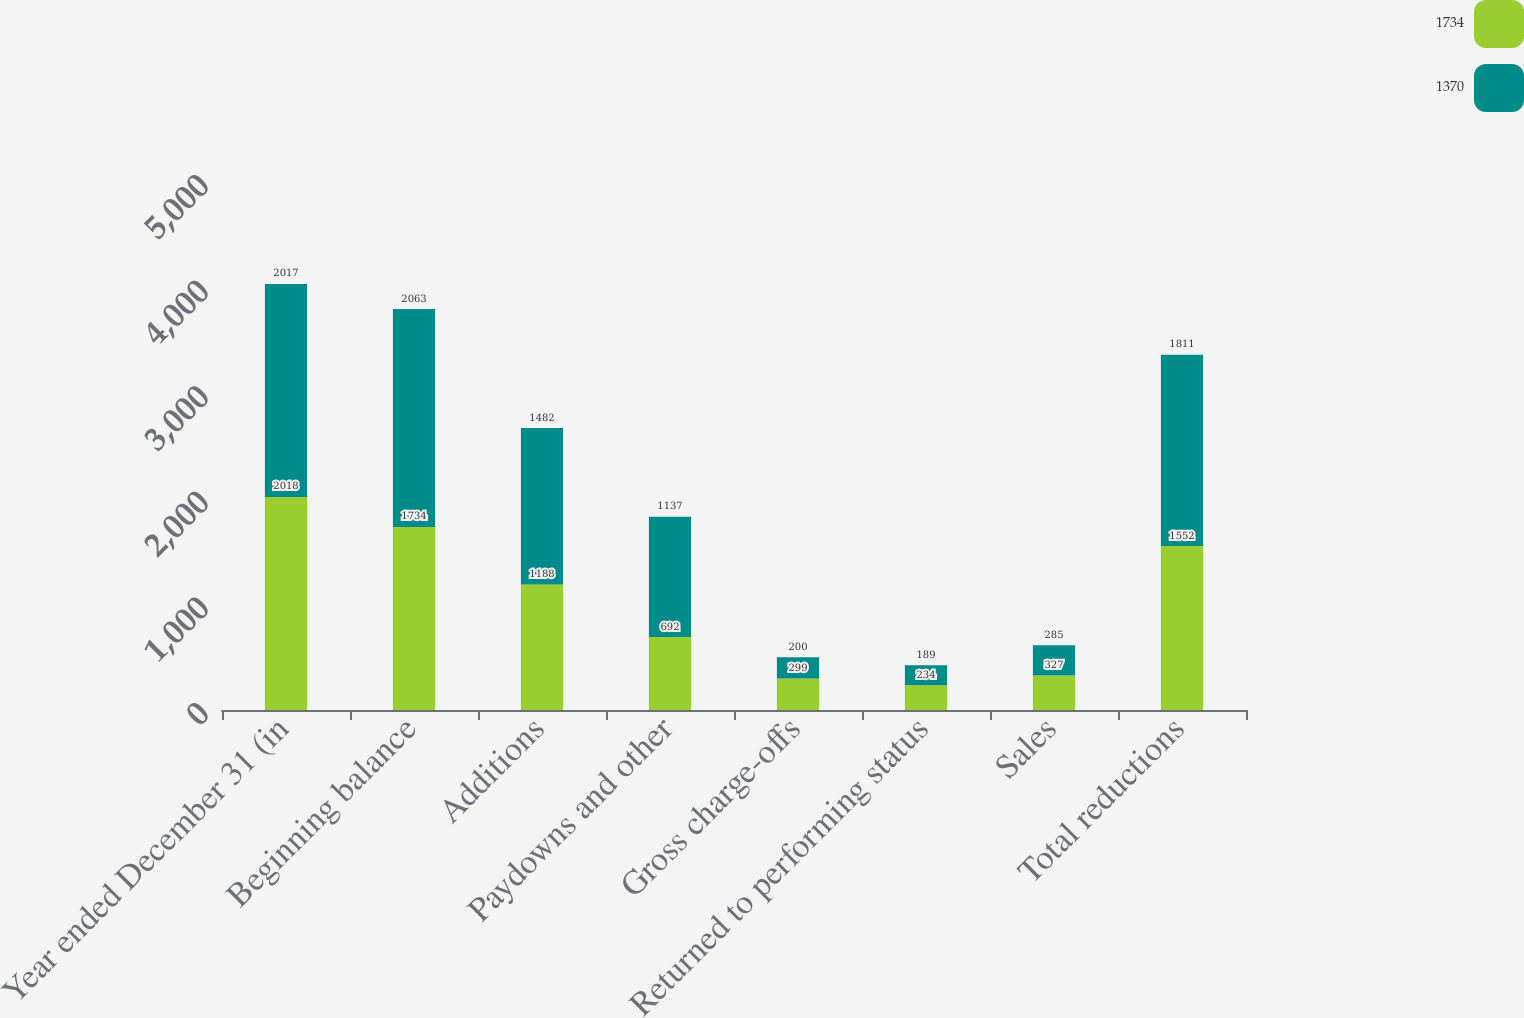Convert chart to OTSL. <chart><loc_0><loc_0><loc_500><loc_500><stacked_bar_chart><ecel><fcel>Year ended December 31 (in<fcel>Beginning balance<fcel>Additions<fcel>Paydowns and other<fcel>Gross charge-offs<fcel>Returned to performing status<fcel>Sales<fcel>Total reductions<nl><fcel>1734<fcel>2018<fcel>1734<fcel>1188<fcel>692<fcel>299<fcel>234<fcel>327<fcel>1552<nl><fcel>1370<fcel>2017<fcel>2063<fcel>1482<fcel>1137<fcel>200<fcel>189<fcel>285<fcel>1811<nl></chart> 